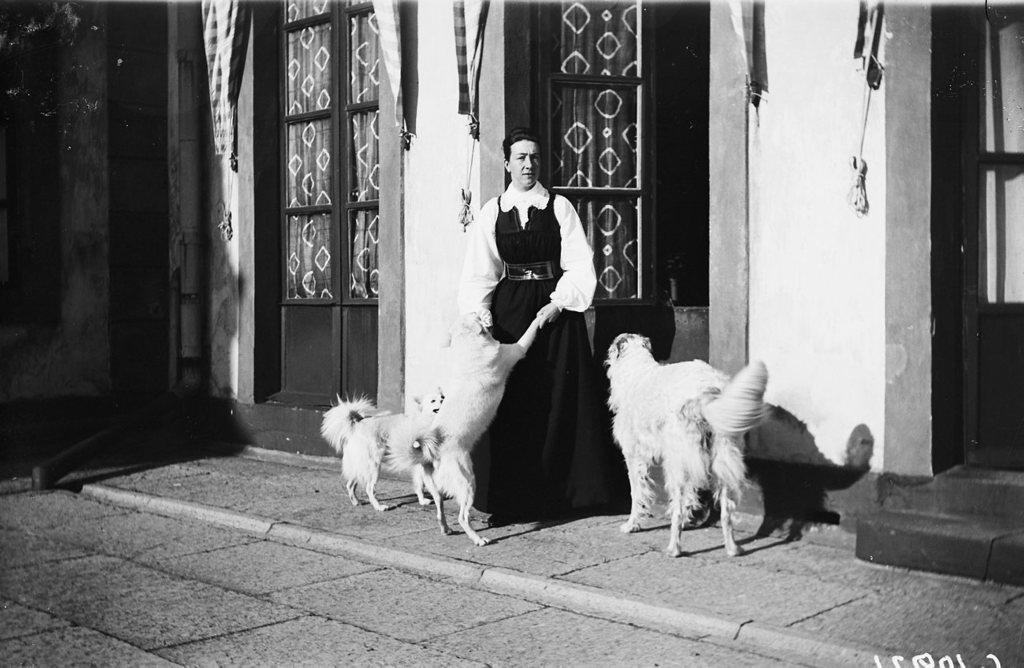Who is present in the image? There is a woman in the image. What is the woman wearing? The woman is wearing a black and white dress. What is the woman doing with one of the dogs? The woman is holding the first two legs of a dog. How many dogs are in the image? There are two dogs in the image. What are the dogs doing in the image? The dogs are looking at the woman. What can be seen in the background of the image? There is a brown door in the background of the image. What is the status of the brown door? The brown door is opened. What historical event is being discussed by the woman and the dogs in the image? There is no indication of any historical event being discussed in the image; the woman is holding a dog, and the dogs are looking at her. 